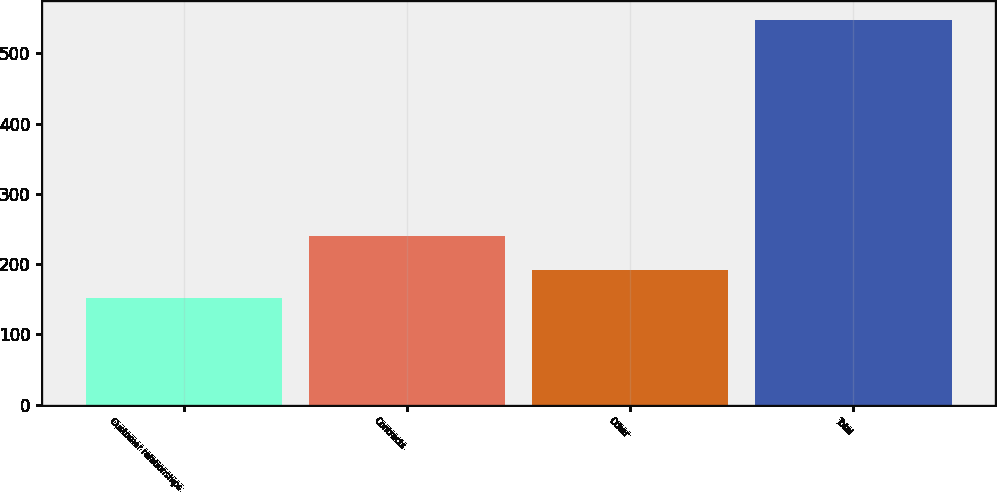<chart> <loc_0><loc_0><loc_500><loc_500><bar_chart><fcel>Customer relationships<fcel>Contracts<fcel>Other<fcel>Total<nl><fcel>152<fcel>240<fcel>191.5<fcel>547<nl></chart> 